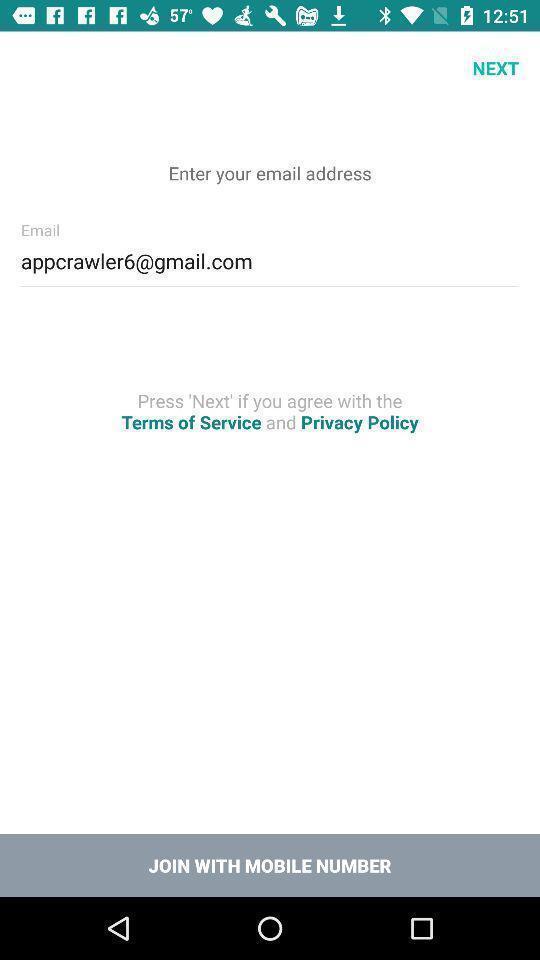Explain the elements present in this screenshot. Sign up menu for an online classrooms app. 